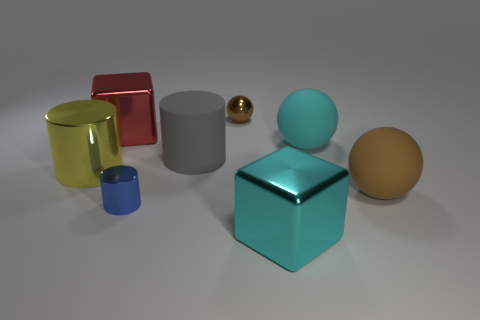How many geometric shapes are visible in the image, and can you name them? There are five distinct geometric shapes visible in the image: two cylinders of different sizes, two cubes, and a sphere. Additionally, there's a smaller sphere that appears golden in color. 